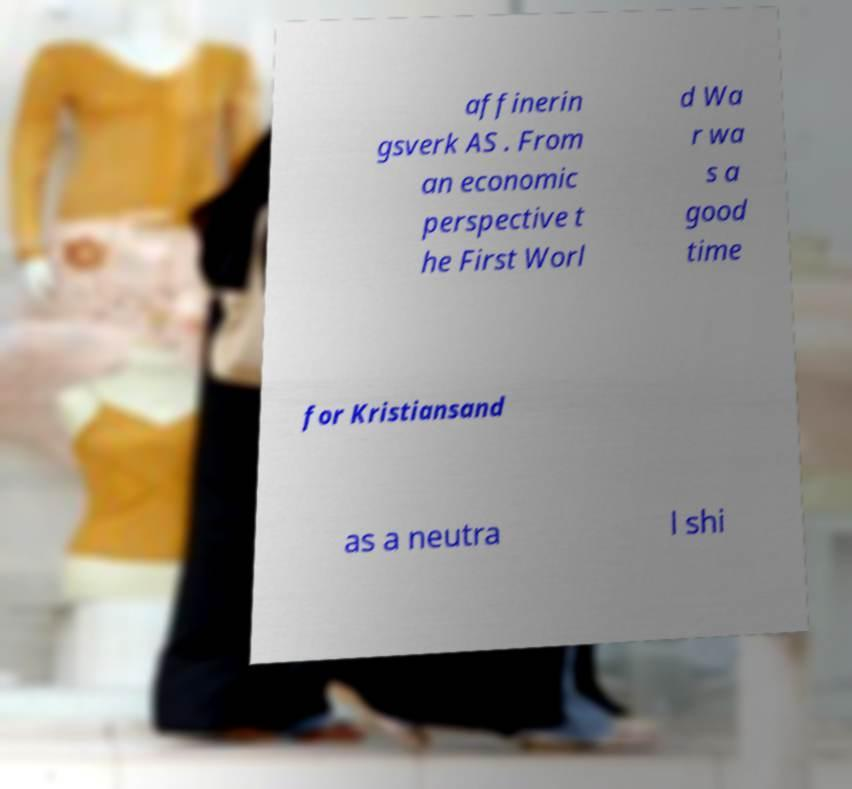Please read and relay the text visible in this image. What does it say? affinerin gsverk AS . From an economic perspective t he First Worl d Wa r wa s a good time for Kristiansand as a neutra l shi 